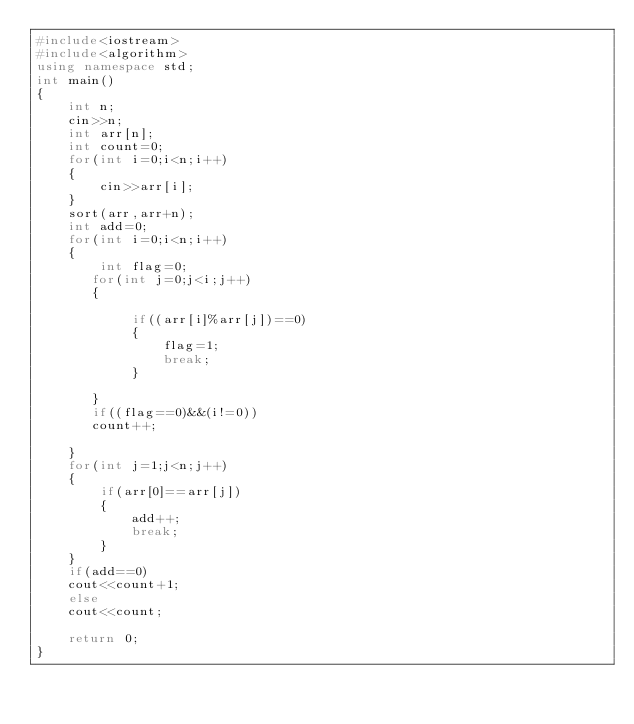Convert code to text. <code><loc_0><loc_0><loc_500><loc_500><_C++_>#include<iostream>
#include<algorithm>
using namespace std;
int main()
{
    int n;
    cin>>n;
    int arr[n];
    int count=0;
    for(int i=0;i<n;i++)
    {
        cin>>arr[i];
    }
    sort(arr,arr+n);
    int add=0;
    for(int i=0;i<n;i++)
    {
        int flag=0;
       for(int j=0;j<i;j++)
       {
        
            if((arr[i]%arr[j])==0)
            {
                flag=1;
                break;
            }
        
       }
       if((flag==0)&&(i!=0))
       count++;
       
    }
    for(int j=1;j<n;j++)
    {
        if(arr[0]==arr[j])
        {
            add++;
            break;
        }
    }
    if(add==0)
    cout<<count+1;
    else
    cout<<count;
    
    return 0;
} </code> 